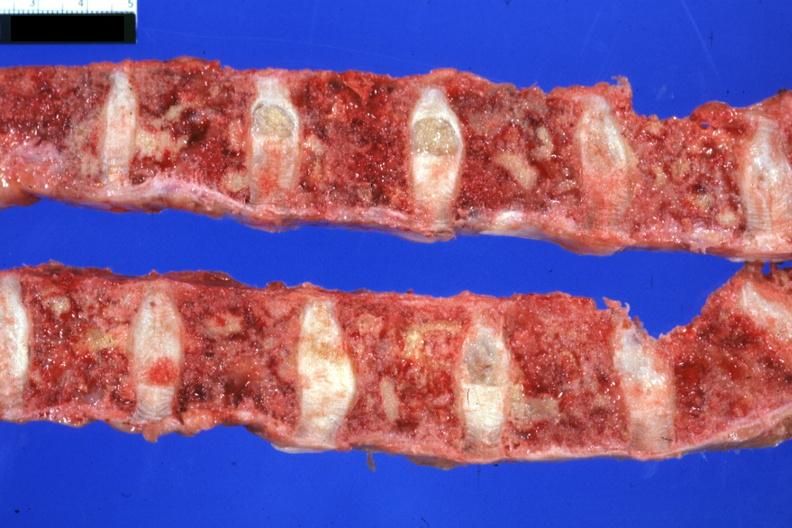how is excellent multiple lesions sigmoid colon papillary 6mo post colon resection with multiple complications?
Answer the question using a single word or phrase. Adenocarcinoma 